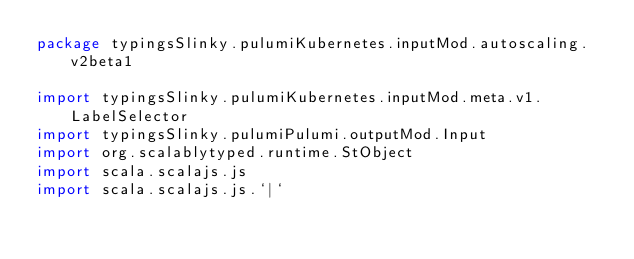Convert code to text. <code><loc_0><loc_0><loc_500><loc_500><_Scala_>package typingsSlinky.pulumiKubernetes.inputMod.autoscaling.v2beta1

import typingsSlinky.pulumiKubernetes.inputMod.meta.v1.LabelSelector
import typingsSlinky.pulumiPulumi.outputMod.Input
import org.scalablytyped.runtime.StObject
import scala.scalajs.js
import scala.scalajs.js.`|`</code> 